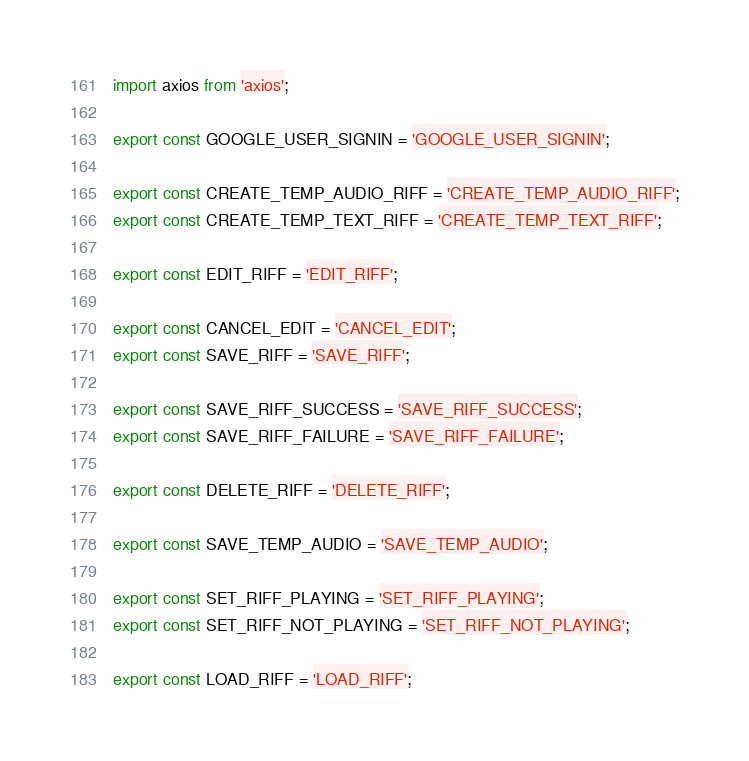Convert code to text. <code><loc_0><loc_0><loc_500><loc_500><_JavaScript_>import axios from 'axios';

export const GOOGLE_USER_SIGNIN = 'GOOGLE_USER_SIGNIN';

export const CREATE_TEMP_AUDIO_RIFF = 'CREATE_TEMP_AUDIO_RIFF';
export const CREATE_TEMP_TEXT_RIFF = 'CREATE_TEMP_TEXT_RIFF';

export const EDIT_RIFF = 'EDIT_RIFF';

export const CANCEL_EDIT = 'CANCEL_EDIT';
export const SAVE_RIFF = 'SAVE_RIFF';

export const SAVE_RIFF_SUCCESS = 'SAVE_RIFF_SUCCESS';
export const SAVE_RIFF_FAILURE = 'SAVE_RIFF_FAILURE';

export const DELETE_RIFF = 'DELETE_RIFF';

export const SAVE_TEMP_AUDIO = 'SAVE_TEMP_AUDIO';

export const SET_RIFF_PLAYING = 'SET_RIFF_PLAYING';
export const SET_RIFF_NOT_PLAYING = 'SET_RIFF_NOT_PLAYING';

export const LOAD_RIFF = 'LOAD_RIFF';</code> 